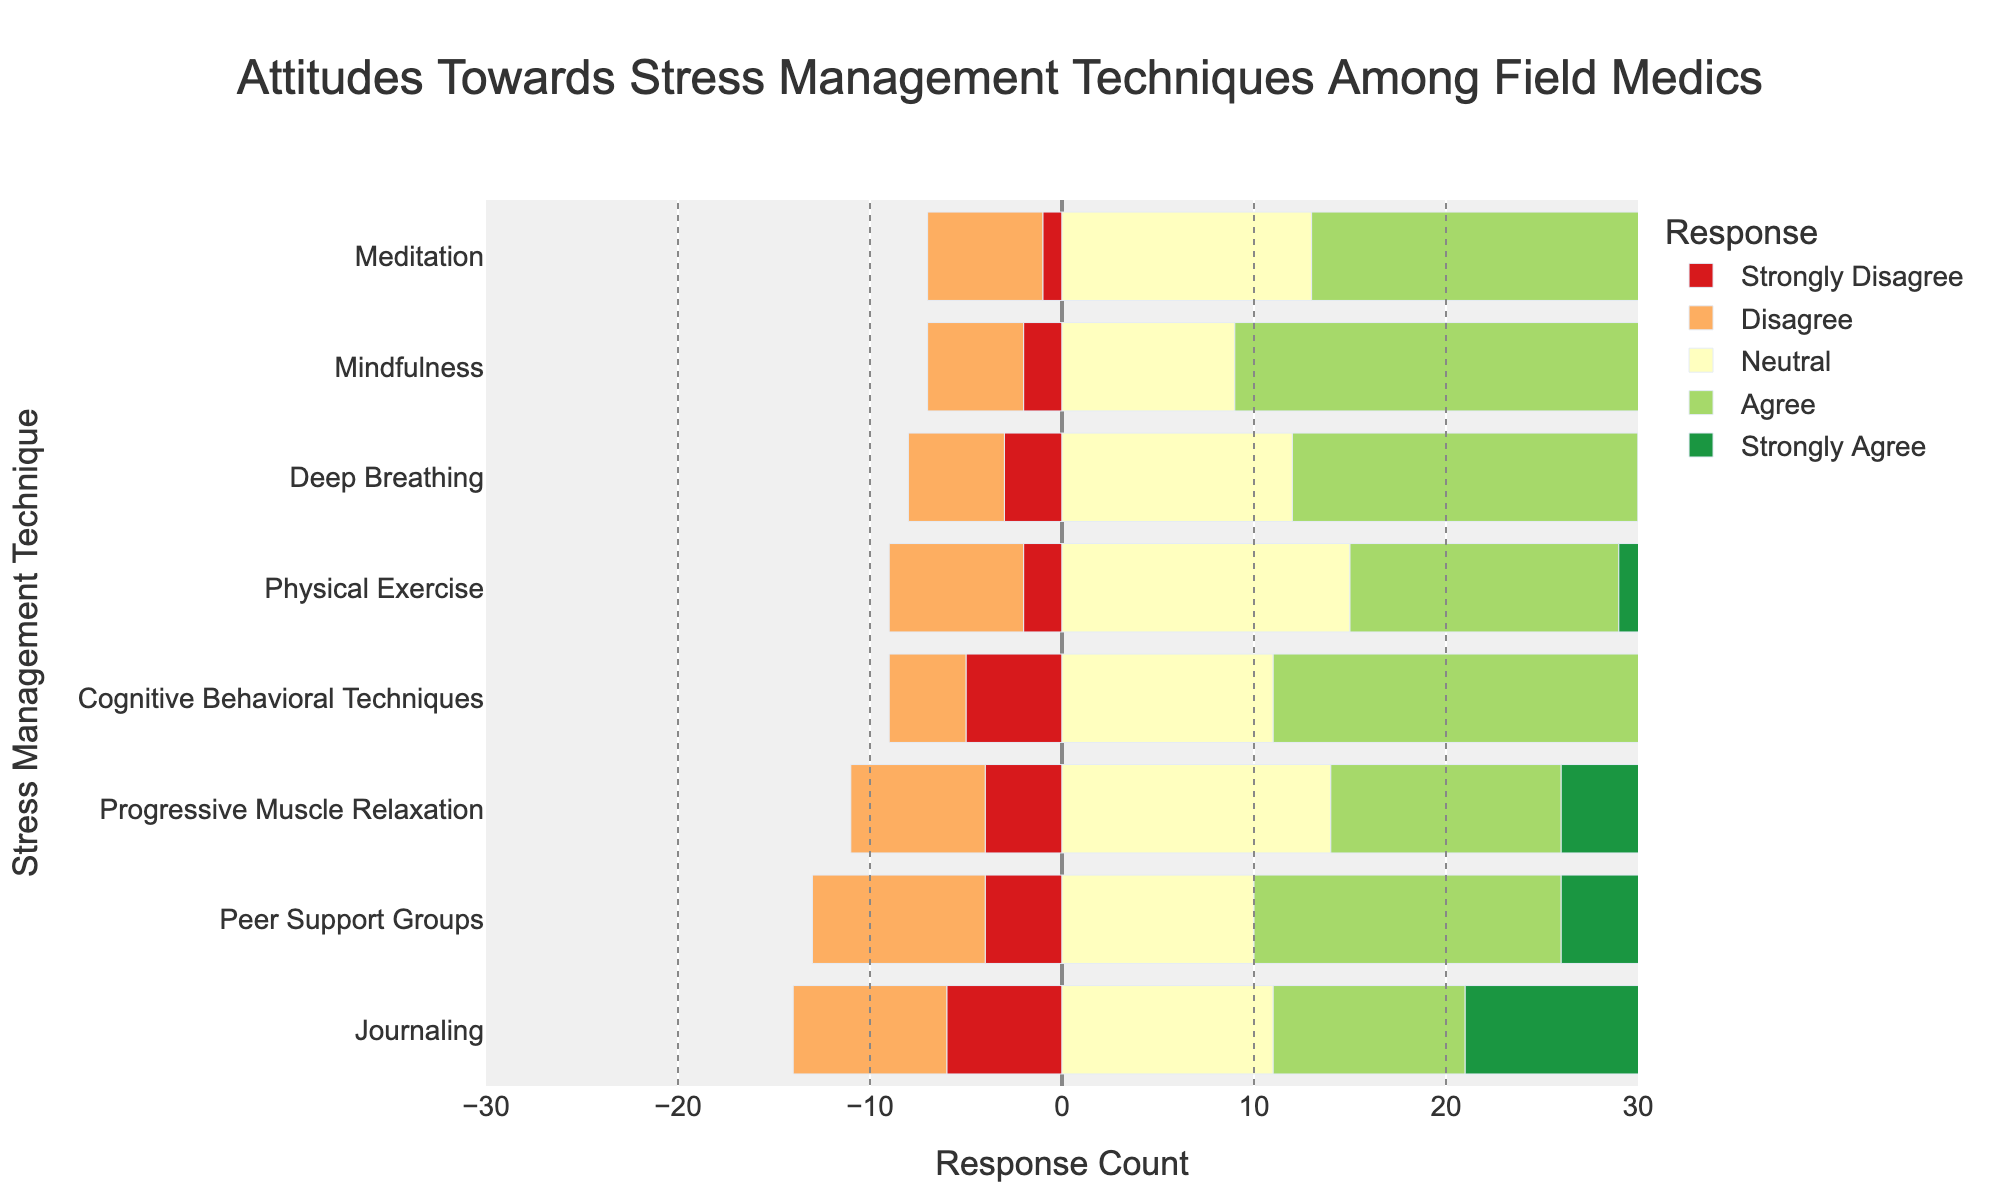What stress management technique do most field medics agree upon? By examining the height of the green bars (representing 'Agree') in the figure, one can identify which technique has the highest 'Agree' count. 'Mindfulness' has the tallest green bar.
Answer: Mindfulness Which technique has the least 'Strongly Disagree' responses? By observing the height of the red bars (representing 'Strongly Disagree') in the figure, one can identify which technique's bar is the shortest. 'Meditation' has the shortest red bar.
Answer: Meditation What is the total count of 'Strongly Agree' responses across all techniques? By summing up all the values of 'Strongly Agree' (purple bars) from the figure: 8 + 6 + 8 + 7 + 6 + 7 + 11 + 9 = 62.
Answer: 62 Comparing 'Meditation' and 'Journaling', which one has a higher combined count of 'Agree' and 'Strongly Agree' responses? By adding the 'Agree' and 'Strongly Agree' counts for 'Meditation' (20+6=26) and 'Journaling' (10+11=21), one can determine that 'Meditation' has a higher combined count.
Answer: Meditation Which technique has the most 'Neutral' responses? By looking at the length of the yellow bars (representing 'Neutral') in the figure, the technique with the longest yellow bar is 'Physical Exercise'.
Answer: Physical Exercise How many more people 'Agree' with 'Peer Support Groups' than 'Disagree' with 'Physical Exercise'? By identifying the count of 'Agree' for 'Peer Support Groups' (16) and 'Disagree' for 'Physical Exercise' (7), and then subtracting (16 - 7 = 9), one can conclude there are 9 more people.
Answer: 9 Which technique has the highest negative sentiment (sum of 'Strongly Disagree' and 'Disagree')? By adding the counts of 'Strongly Disagree' and 'Disagree' for each technique and comparing them, 'Peer Support Groups' has the highest negative sentiment (4+9=13).
Answer: Peer Support Groups Which two techniques have the exact same number of 'Neutral' responses? By comparing the counts of 'Neutral' responses visually, 'Journaling' and 'Cognitive Behavioral Techniques' both have 11 'Neutral' responses.
Answer: Journaling and Cognitive Behavioral Techniques What is the combined total count of 'Agree' and 'Strongly Agree' responses for 'Deep Breathing' and 'Mindfulness'? Adding the values of 'Agree' and 'Strongly Agree' for both 'Deep Breathing' (18+8=26) and 'Mindfulness' (23+7=30) and summing them up (26 + 30=56) gives the result.
Answer: 56 Which stress management technique has the lowest combined count of 'Disagree' and 'Strongly Disagree' responses? By summing the 'Disagree' and 'Strongly Disagree' counts for each technique and comparing them, 'Meditation' has the lowest combined count (1+6=7).
Answer: Meditation 